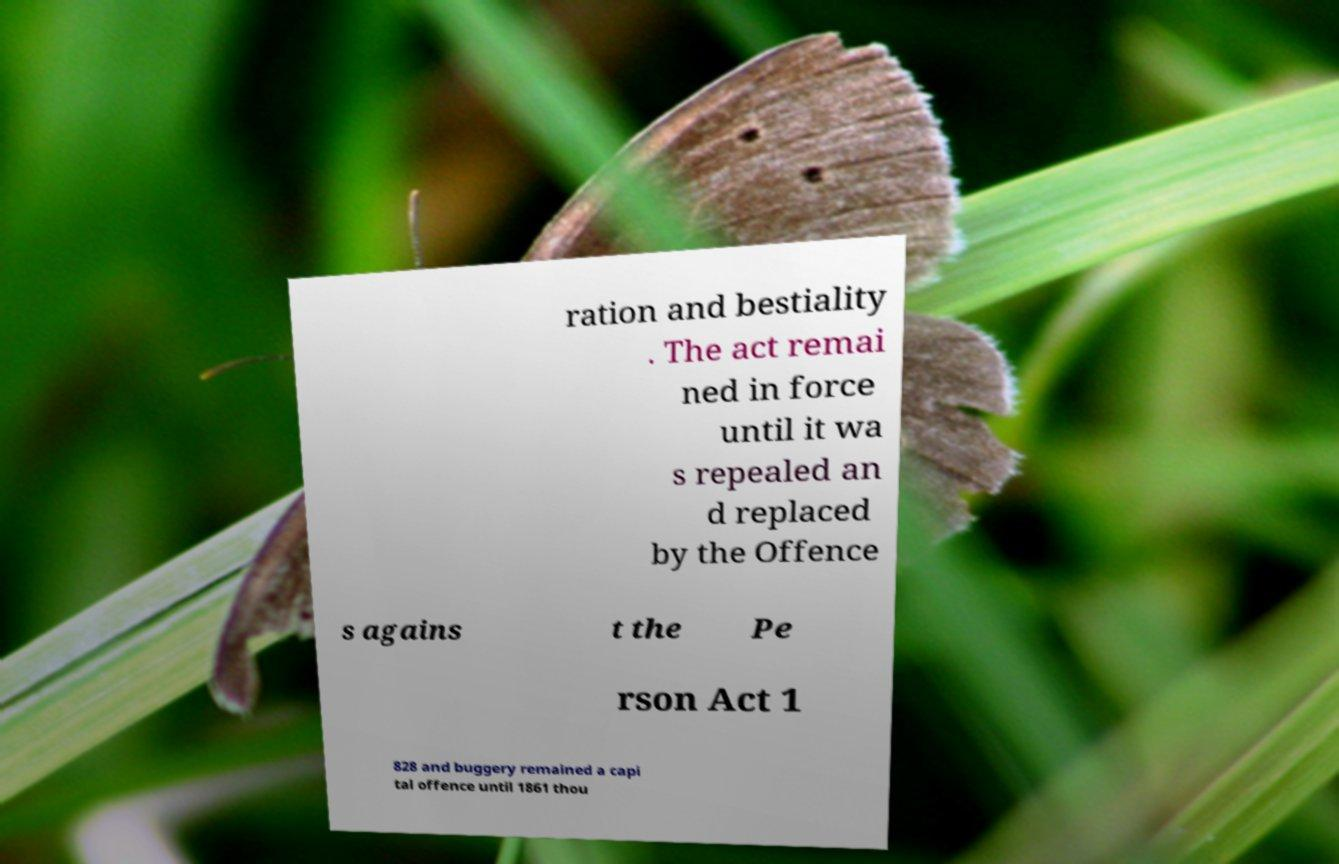Please identify and transcribe the text found in this image. ration and bestiality . The act remai ned in force until it wa s repealed an d replaced by the Offence s agains t the Pe rson Act 1 828 and buggery remained a capi tal offence until 1861 thou 